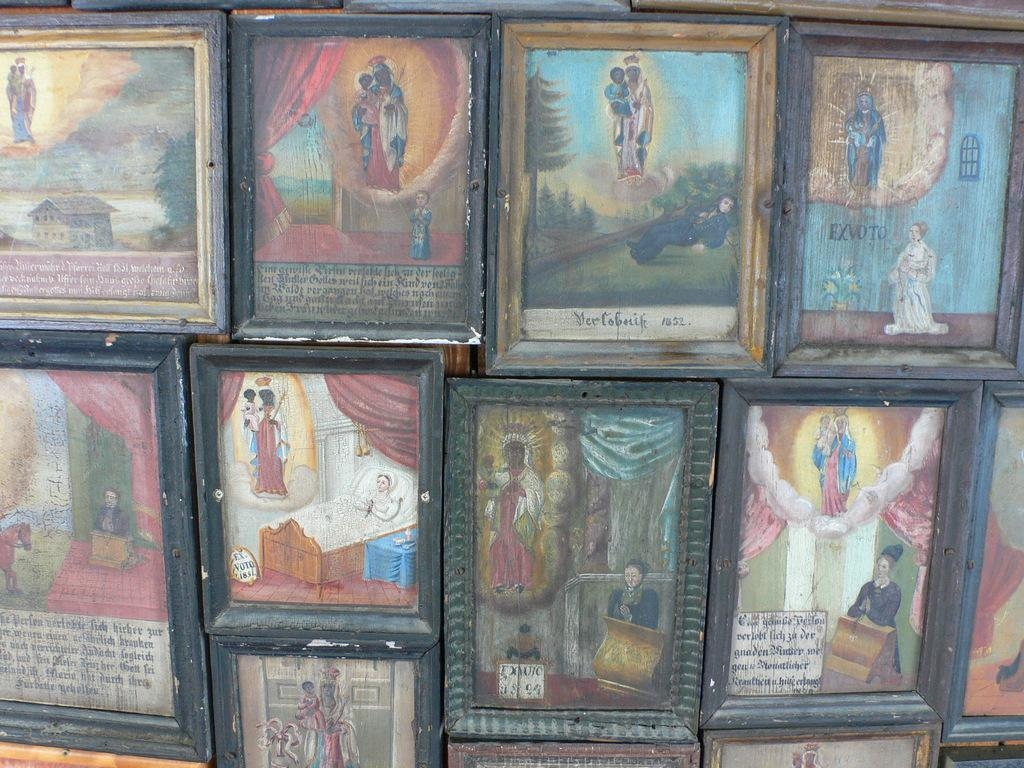<image>
Give a short and clear explanation of the subsequent image. Paintings have their artist's name on front to signify who created it. 